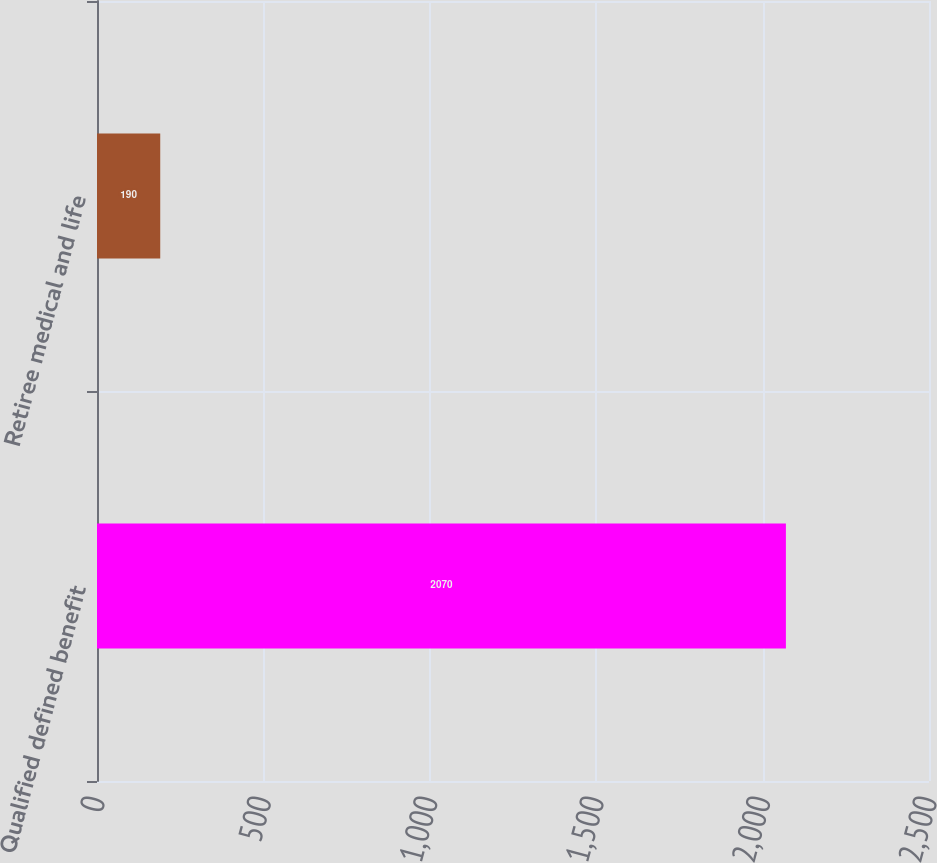Convert chart to OTSL. <chart><loc_0><loc_0><loc_500><loc_500><bar_chart><fcel>Qualified defined benefit<fcel>Retiree medical and life<nl><fcel>2070<fcel>190<nl></chart> 